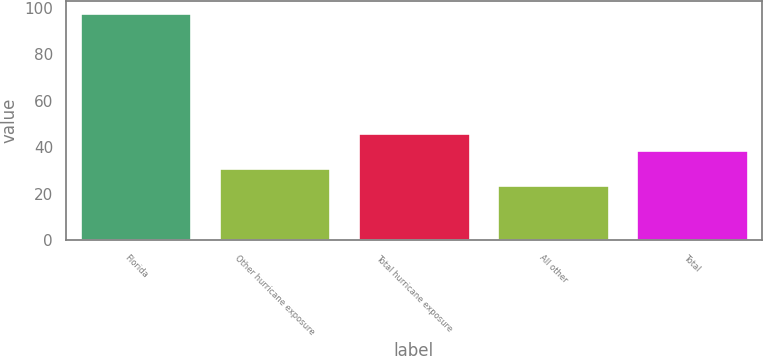Convert chart. <chart><loc_0><loc_0><loc_500><loc_500><bar_chart><fcel>Florida<fcel>Other hurricane exposure<fcel>Total hurricane exposure<fcel>All other<fcel>Total<nl><fcel>97.9<fcel>31.3<fcel>46.1<fcel>23.9<fcel>38.7<nl></chart> 